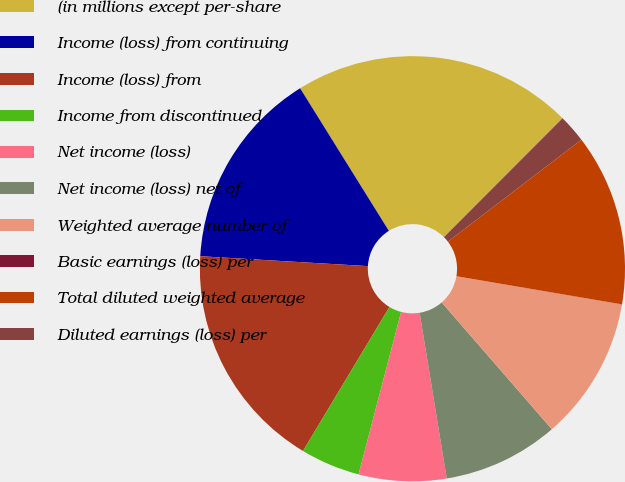Convert chart. <chart><loc_0><loc_0><loc_500><loc_500><pie_chart><fcel>(in millions except per-share<fcel>Income (loss) from continuing<fcel>Income (loss) from<fcel>Income from discontinued<fcel>Net income (loss)<fcel>Net income (loss) net of<fcel>Weighted average number of<fcel>Basic earnings (loss) per<fcel>Total diluted weighted average<fcel>Diluted earnings (loss) per<nl><fcel>21.34%<fcel>15.2%<fcel>17.33%<fcel>4.53%<fcel>6.66%<fcel>8.8%<fcel>10.93%<fcel>0.01%<fcel>13.06%<fcel>2.14%<nl></chart> 